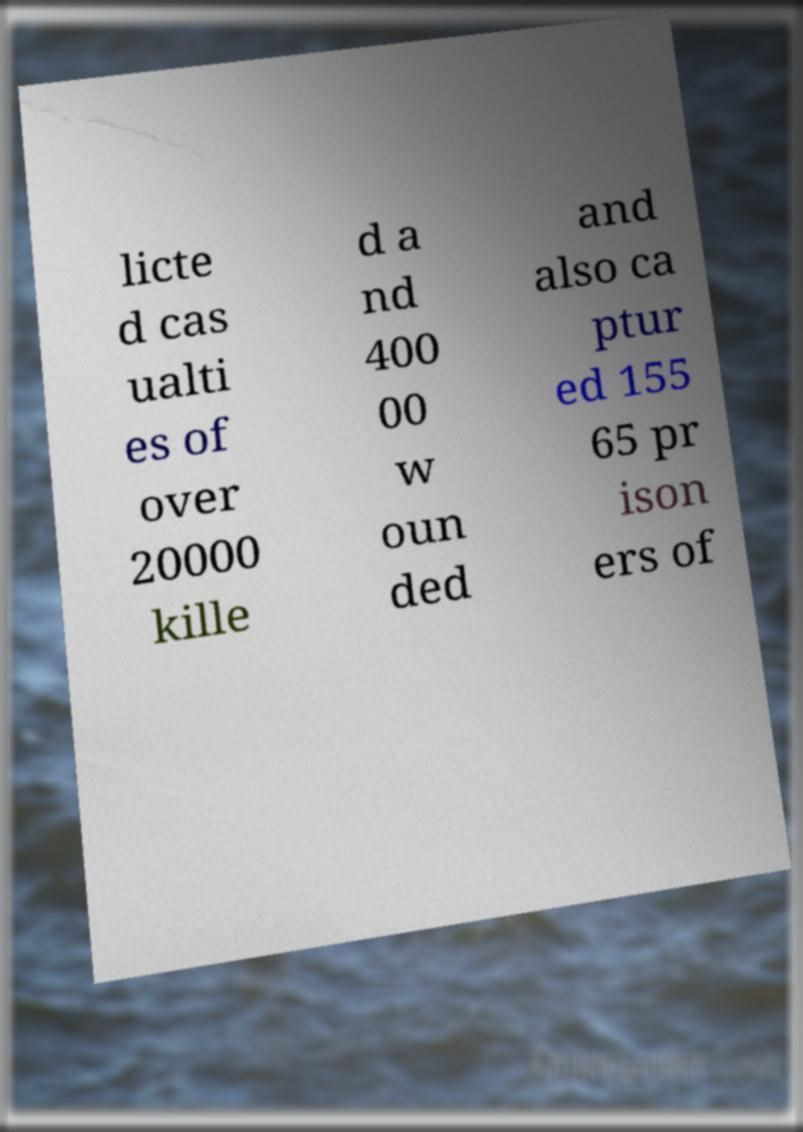Could you extract and type out the text from this image? licte d cas ualti es of over 20000 kille d a nd 400 00 w oun ded and also ca ptur ed 155 65 pr ison ers of 